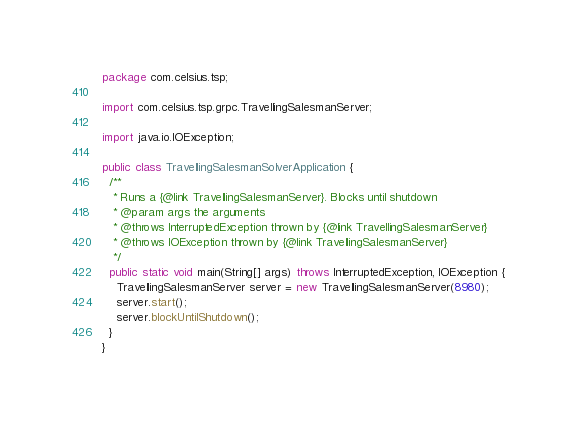Convert code to text. <code><loc_0><loc_0><loc_500><loc_500><_Java_>package com.celsius.tsp;

import com.celsius.tsp.grpc.TravellingSalesmanServer;

import java.io.IOException;

public class TravellingSalesmanSolverApplication {
  /**
   * Runs a {@link TravellingSalesmanServer}. Blocks until shutdown
   * @param args the arguments
   * @throws InterruptedException thrown by {@link TravellingSalesmanServer}
   * @throws IOException thrown by {@link TravellingSalesmanServer}
   */
  public static void main(String[] args) throws InterruptedException, IOException {
    TravellingSalesmanServer server = new TravellingSalesmanServer(8980);
    server.start();
    server.blockUntilShutdown();
  }
}
</code> 